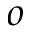<formula> <loc_0><loc_0><loc_500><loc_500>o</formula> 